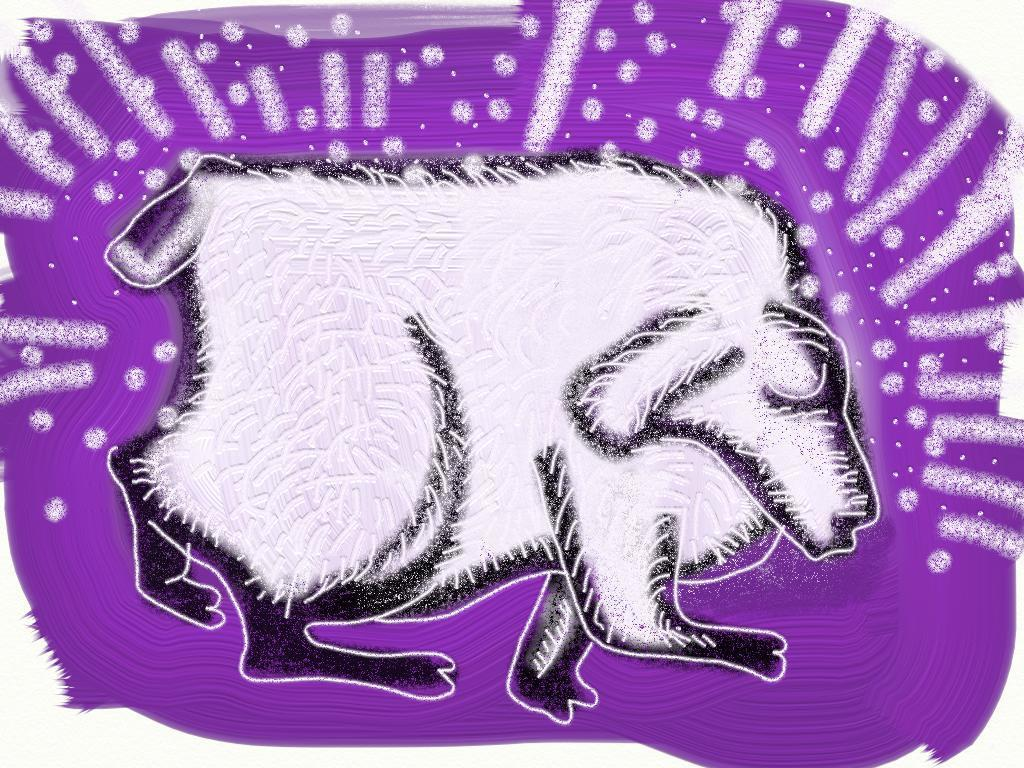What is depicted in the image? There is a picture of an animal in the image. What color is the background around the animal? The background color around the animal is violet. Are there any additional elements in the image besides the animal? Yes, there are designs present in the image. What type of whip is being advertised in the image? There is no whip or advertisement present in the image; it features a picture of an animal with a violet background and designs. How many toes can be seen on the animal in the image? The image does not show the animal's toes, as it only depicts a picture of the animal with a violet background and designs. 